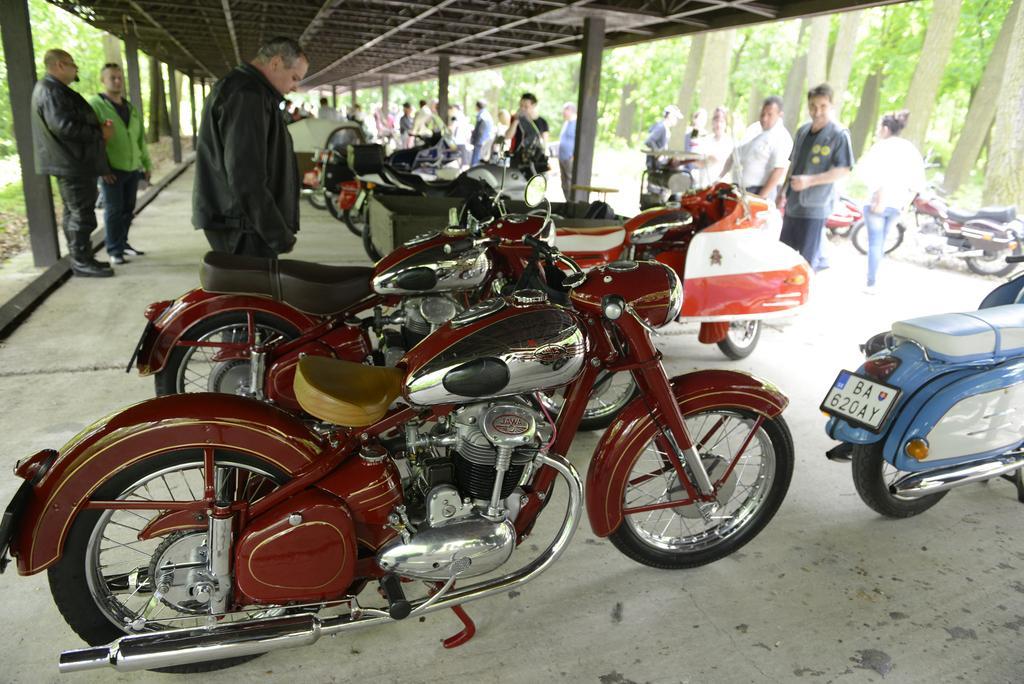How would you summarize this image in a sentence or two? In this image it looks like it is a parking place in which there are so many bikes parked under the shed. On the right side there are few people standing on the road. Beside them there are trees. On the left side there are pillars. There are two persons standing near the pillar. 